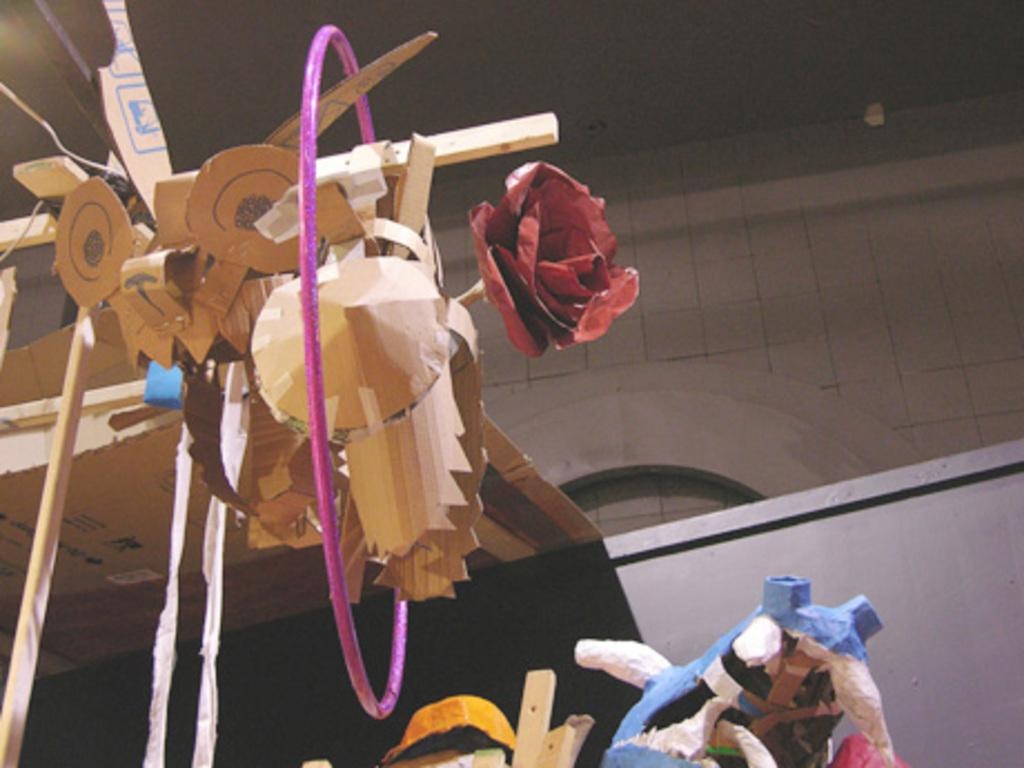What type of toys are present in the image? There are wooden toys in the image. What can be seen in the background of the image? There is a wall in the background of the image. What type of collar can be seen on the wooden toys in the image? There are no collars present on the wooden toys in the image, as they are inanimate objects and do not wear collars. 